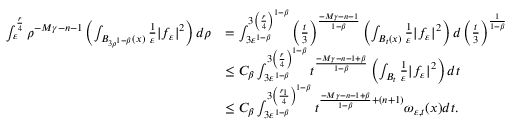<formula> <loc_0><loc_0><loc_500><loc_500>\begin{array} { r l } { \int _ { \varepsilon } ^ { \frac { r } { 4 } } \rho ^ { - M \gamma - n - 1 } \left ( \int _ { B _ { 3 \rho ^ { 1 - \beta } } ( x ) } \frac { 1 } { \varepsilon } | f _ { \varepsilon } | ^ { 2 } \right ) d \rho } & { = \int _ { 3 \varepsilon ^ { 1 - \beta } } ^ { 3 \left ( \frac { r } { 4 } \right ) ^ { 1 - \beta } } \left ( \frac { t } { 3 } \right ) ^ { \frac { - M \gamma - n - 1 } { 1 - \beta } } \left ( \int _ { B _ { t } ( x ) } \frac { 1 } { \varepsilon } | f _ { \varepsilon } | ^ { 2 } \right ) d \left ( \frac { t } { 3 } \right ) ^ { \frac { 1 } { 1 - \beta } } } \\ & { \leq C _ { \beta } \int _ { 3 \varepsilon ^ { 1 - \beta } } ^ { 3 \left ( \frac { r } { 4 } \right ) ^ { 1 - \beta } } t ^ { \frac { - M \gamma - n - 1 + \beta } { 1 - \beta } } \left ( \int _ { B _ { t } } \frac { 1 } { \varepsilon } | f _ { \varepsilon } | ^ { 2 } \right ) d t } \\ & { \leq C _ { \beta } \int _ { 3 \varepsilon ^ { 1 - \beta } } ^ { 3 \left ( \frac { r _ { 1 } } { 4 } \right ) ^ { 1 - \beta } } t ^ { \frac { - M \gamma - n - 1 + \beta } { 1 - \beta } + ( n + 1 ) } \omega _ { \varepsilon , t } ( x ) d t . } \end{array}</formula> 